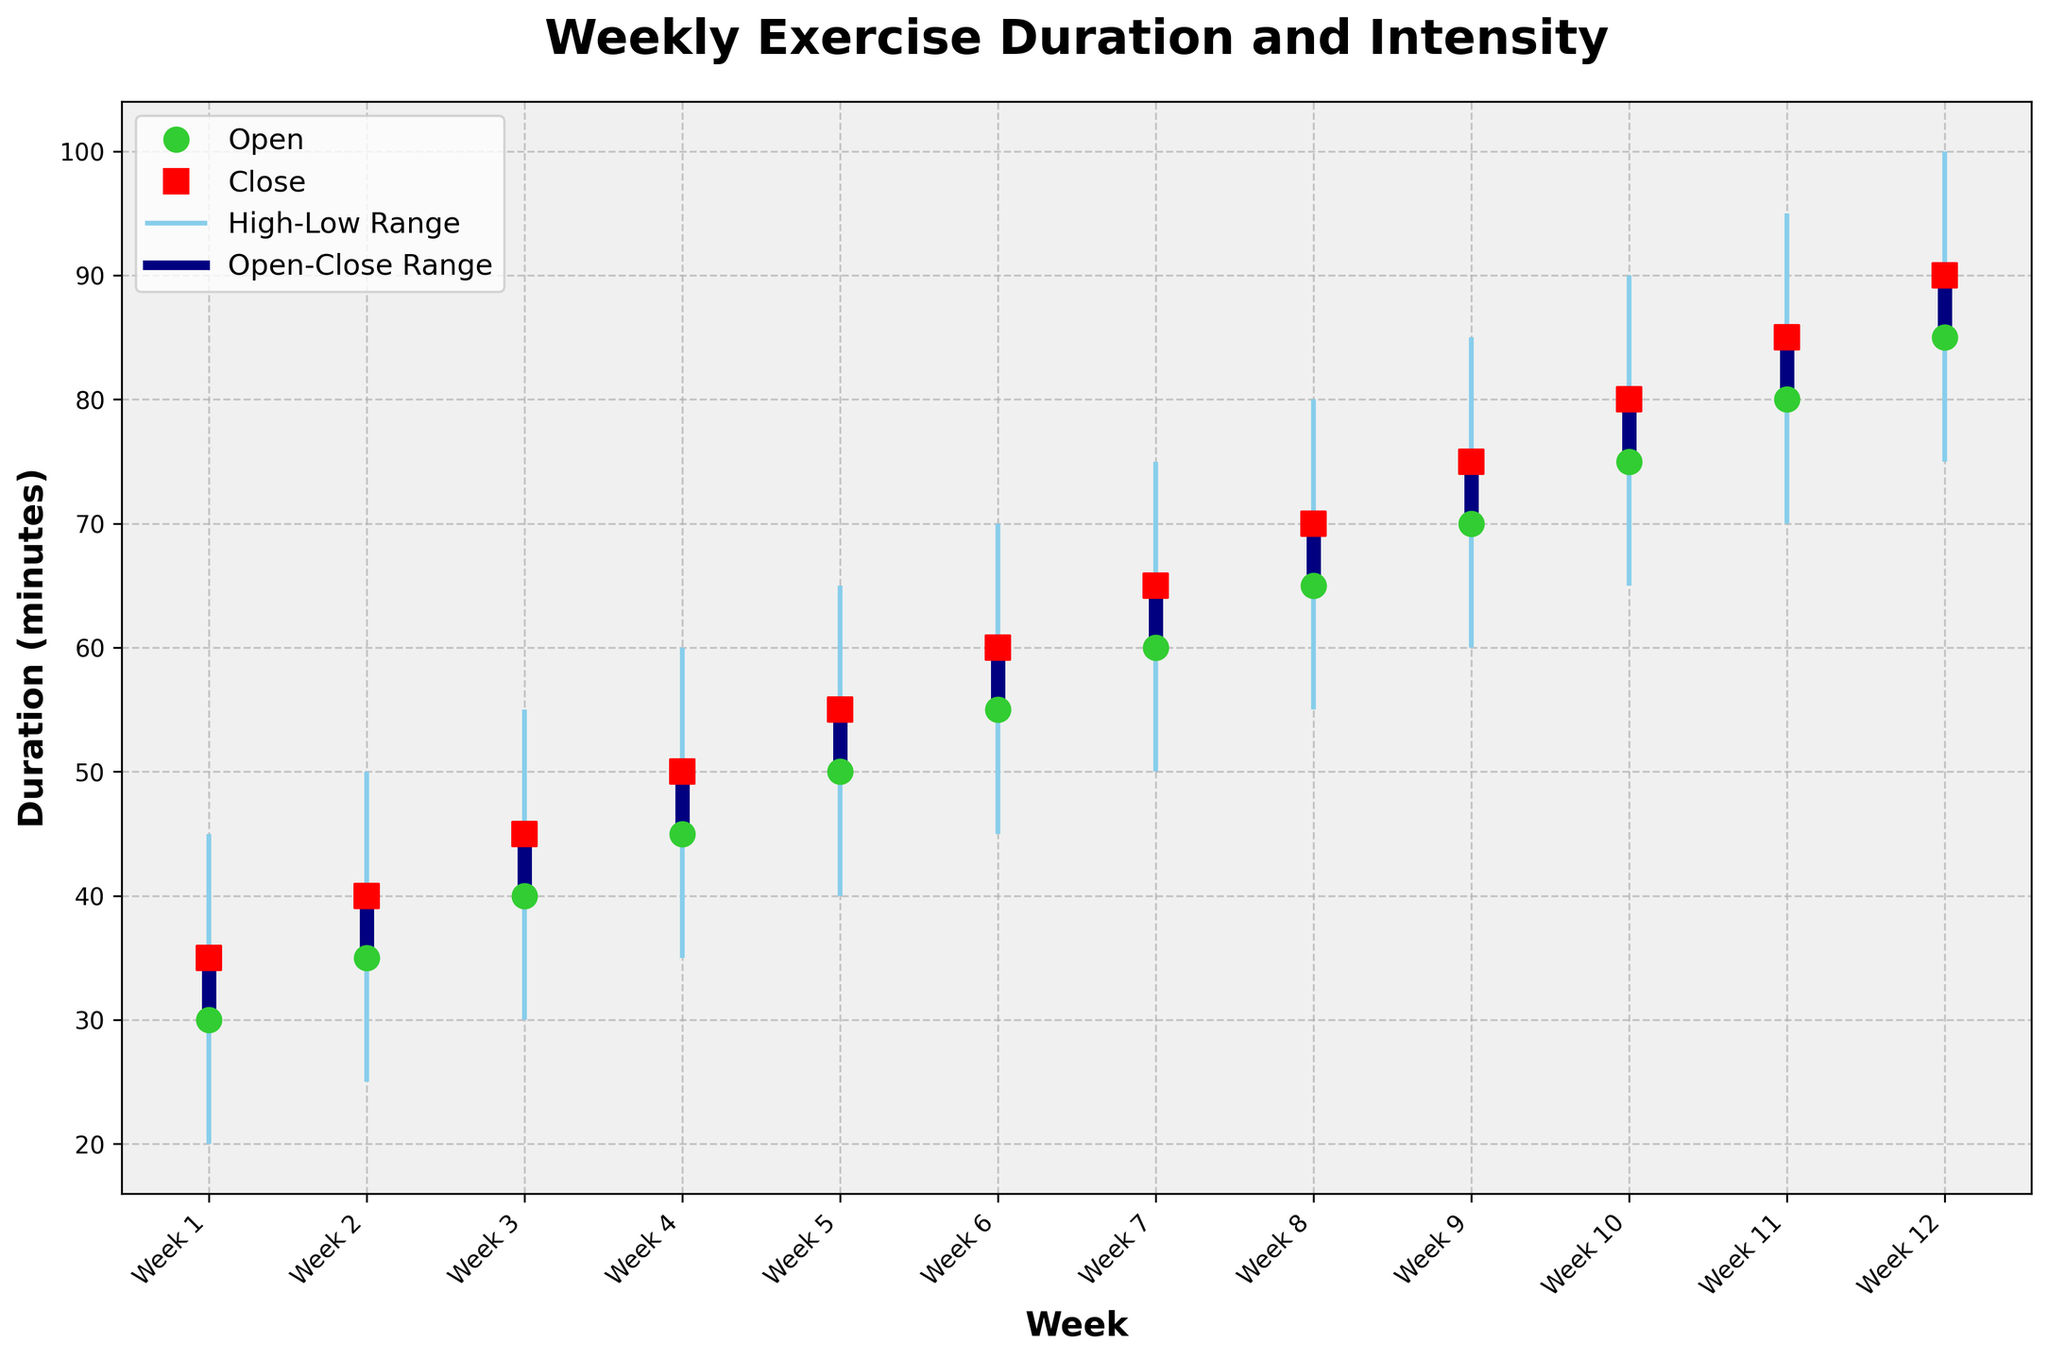What is the title of the figure? The title can be found at the top of the figure, it is typically a short description of what the chart represents.
Answer: Weekly Exercise Duration and Intensity What are the axes labels in the figure? The x-axis and y-axis labels give contextual information about what data is represented on each axis, the x-axis label is found at the bottom and the y-axis label on the side.
Answer: Weeks, Duration (minutes) Which week has the highest exercise duration recorded and how much is it? To find this, look for the week with the highest point on the "high" range. The highest duration value on the High column indicates the highest exercise duration.
Answer: Week 12, 100 minutes What is the open and close exercise duration for Week 5? To determine this, find Week 5 on the x-axis, then refer to the open and close markers, which are indicated by different colors with markers 'o' and 's'.
Answer: Open: 50 minutes, Close: 55 minutes How does the exercise duration change from Week 1 to Week 2? To answer, compare the open and close values between Week 1 and Week 2 by looking at the corresponding positions on the x-axis.
Answer: From 35 minutes close in Week 1 to 40 minutes close in Week 2 Calculate the average high point for the first 6 weeks. Sum up the high points from Week 1 to Week 6 and divide by the number of weeks (6). These high points are 45, 50, 55, 60, 65, and 70.
Answer: Average = (45 + 50 + 55 + 60 + 65 + 70) / 6 = 57.5 In which week does the largest difference between high and low exercise duration occur and what is that difference? Calculate the difference between high and low for each week and identify the maximum difference. From the data, it's clear difference (high-low) for each week is: 25, 25, 25, 25, 25, 25, 25, 25, 25, 25, 25, 25. They are all 25.
Answer: Any of the weeks (all differences are 25 minutes) What is the trend in the open exercise duration from Week 1 to Week 12? Look at the 'open' values for each week to determine whether the duration is increasing, decreasing, or remaining constant over time. Notice the values increasing progressively every week by 5 minutes.
Answer: Increasing trend Between which two consecutive weeks is the increase in closing duration the greatest and how much is that increase? Look at the 'close' values for each week and identify the greatest difference between two consecutive weeks. The closing duration values for consecutive increases are: 35, 40, 45, 50, 55, 60, 65, 70, 75, 80, 85, 90. The largest increase is 5 minutes, occurring between each consecutive week.
Answer: Any consecutive week pairs (5 minutes increase) What does a vertical line segment on the figure represent? A vertical line segment indicates the range of exercise duration for a week, from the lowest recorded duration to the highest recorded duration, or from the open to the close exercise duration.
Answer: High-Low Range 